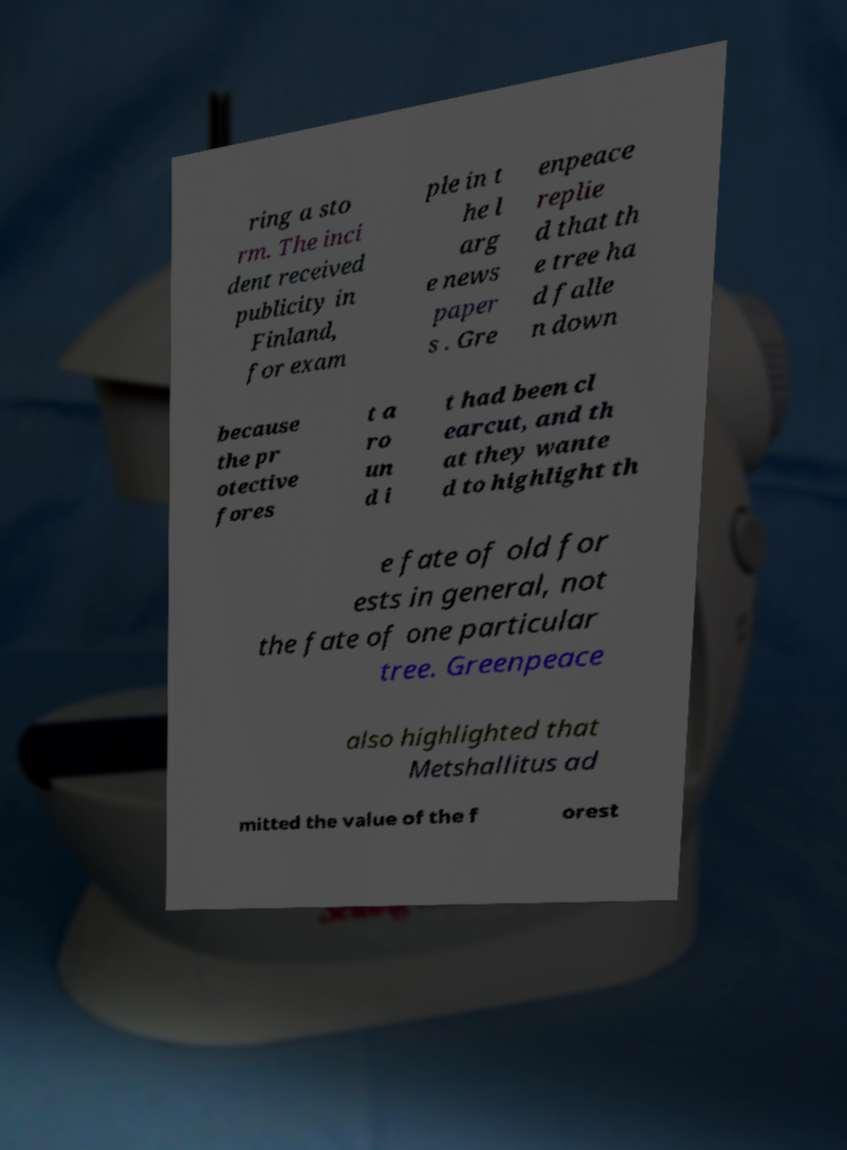Can you accurately transcribe the text from the provided image for me? ring a sto rm. The inci dent received publicity in Finland, for exam ple in t he l arg e news paper s . Gre enpeace replie d that th e tree ha d falle n down because the pr otective fores t a ro un d i t had been cl earcut, and th at they wante d to highlight th e fate of old for ests in general, not the fate of one particular tree. Greenpeace also highlighted that Metshallitus ad mitted the value of the f orest 